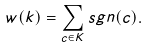<formula> <loc_0><loc_0><loc_500><loc_500>w ( k ) = \sum _ { c \in K } s g n ( c ) .</formula> 